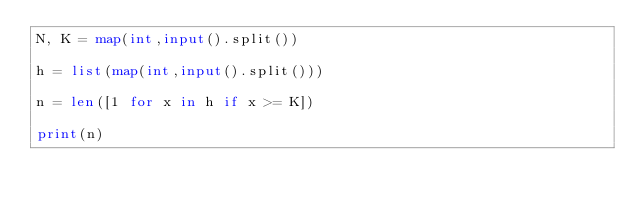Convert code to text. <code><loc_0><loc_0><loc_500><loc_500><_Python_>N, K = map(int,input().split())

h = list(map(int,input().split()))

n = len([1 for x in h if x >= K])

print(n)</code> 